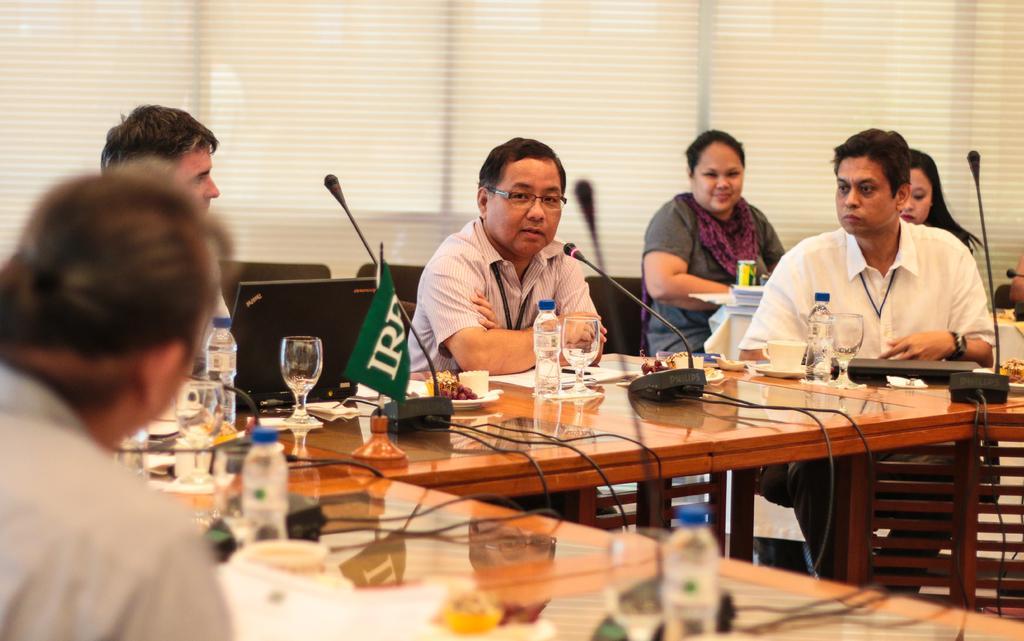Can you describe this image briefly? In this image, group of peoples are sat on the black chairs. There are few tables are placed in-front of them. We can see few items are placed on it. And background, we can see windows and shades. 